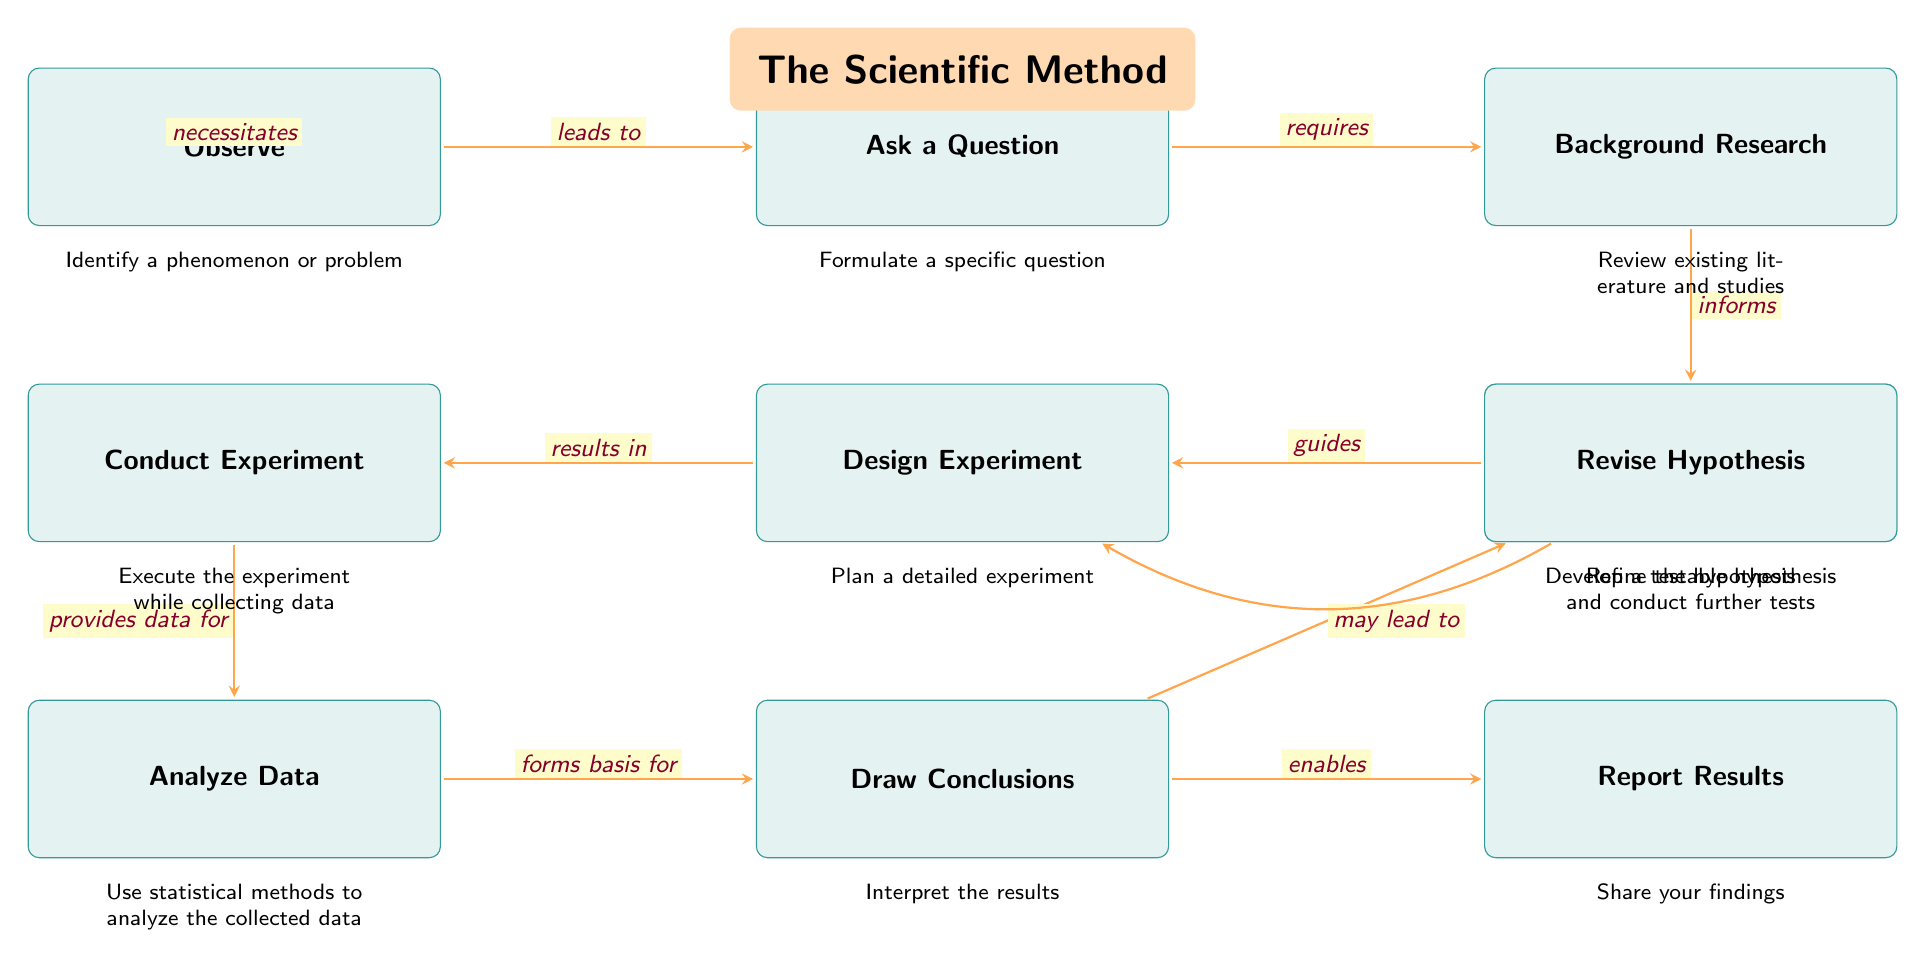What is the first step in the scientific method flowchart? The first step listed in the flowchart is "Observe." This is identified as the starting point of the scientific method process.
Answer: Observe How many main steps are in the scientific method flowchart? There are ten main steps shown in the flowchart. This can be counted from the nodes listed, which are all sequentially connected.
Answer: 10 What follows after "Background Research"? After "Background Research," the next step is "Construct a Hypothesis." This connection is represented by an arrow leading directly from "Background Research" to "Construct a Hypothesis."
Answer: Construct a Hypothesis Which step may lead to the "Design Experiment"? "Revise Hypothesis" may lead to "Design Experiment." This is indicated by the back arrow from "Revise Hypothesis" that points back to "Design Experiment," showing a circular relationship.
Answer: Revise Hypothesis What relationship exists between "Conduct Experiment" and "Analyze Data"? The relationship is that "Conduct Experiment" provides data for "Analyze Data." This is indicated by the arrow that flows from "Conduct Experiment" pointing towards "Analyze Data."
Answer: provides data for What is the purpose of the "Draw Conclusions" step? "Draw Conclusions" interprets the results from the analysis conducted in the preceding step. The flowchart indicates that "Draw Conclusions" is based on the analysis performed in the previous "Analyze Data" step.
Answer: Interpret the results How many connections (arrows) are there in the diagram? There are nine connections (arrows) illustrated in the diagram, showing the various relationships between each step in the scientific method. This is derived from counting all the arrow connections between the boxes.
Answer: 9 What step comes immediately before "Report Results"? The step that comes immediately before "Report Results" is "Draw Conclusions." This is a direct link as indicated in the flowchart with an arrow leading from "Draw Conclusions" to "Report Results."
Answer: Draw Conclusions What does "Construct a Hypothesis" guide? "Construct a Hypothesis" guides "Design Experiment." This is shown by the arrow leading from "Construct a Hypothesis" to "Design Experiment" in the flowchart, indicating the relationship.
Answer: Design Experiment 